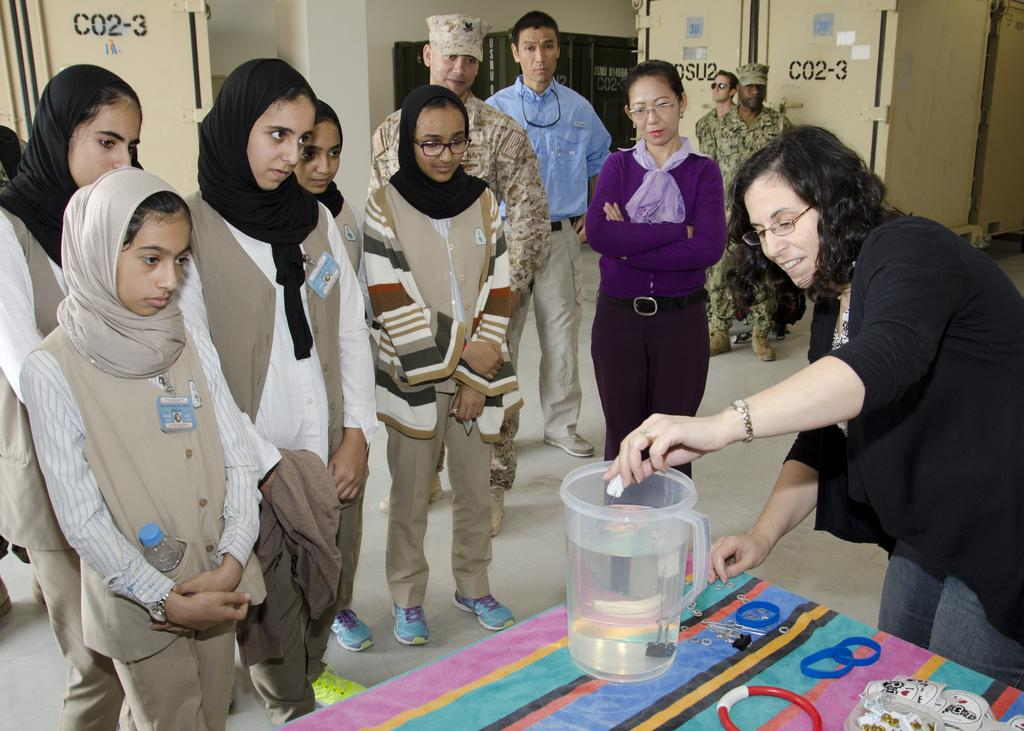<image>
Present a compact description of the photo's key features. A group of people watch a woman at a table the walls in the room say co2-3. 